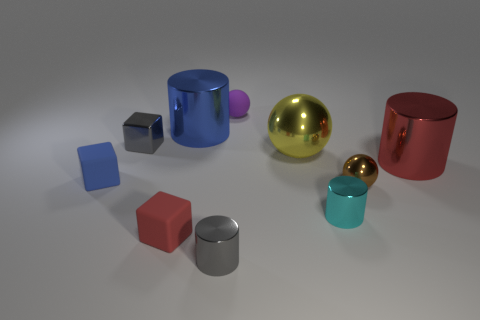How many other objects are the same shape as the small blue thing?
Your response must be concise. 2. What is the shape of the red matte thing?
Offer a terse response. Cube. Does the small cyan object have the same material as the large yellow ball?
Provide a short and direct response. Yes. Are there the same number of large objects right of the small purple sphere and blocks behind the small cyan cylinder?
Your answer should be compact. Yes. There is a big metallic cylinder behind the red object behind the tiny blue rubber block; are there any large blue metallic cylinders left of it?
Offer a terse response. No. Do the brown thing and the blue shiny thing have the same size?
Your answer should be very brief. No. There is a tiny matte thing behind the metallic block on the left side of the ball in front of the blue rubber thing; what is its color?
Offer a very short reply. Purple. What number of small blocks are the same color as the small metallic ball?
Keep it short and to the point. 0. How many small things are either red metallic spheres or yellow balls?
Offer a terse response. 0. Is there a matte thing of the same shape as the cyan metal thing?
Offer a very short reply. No. 